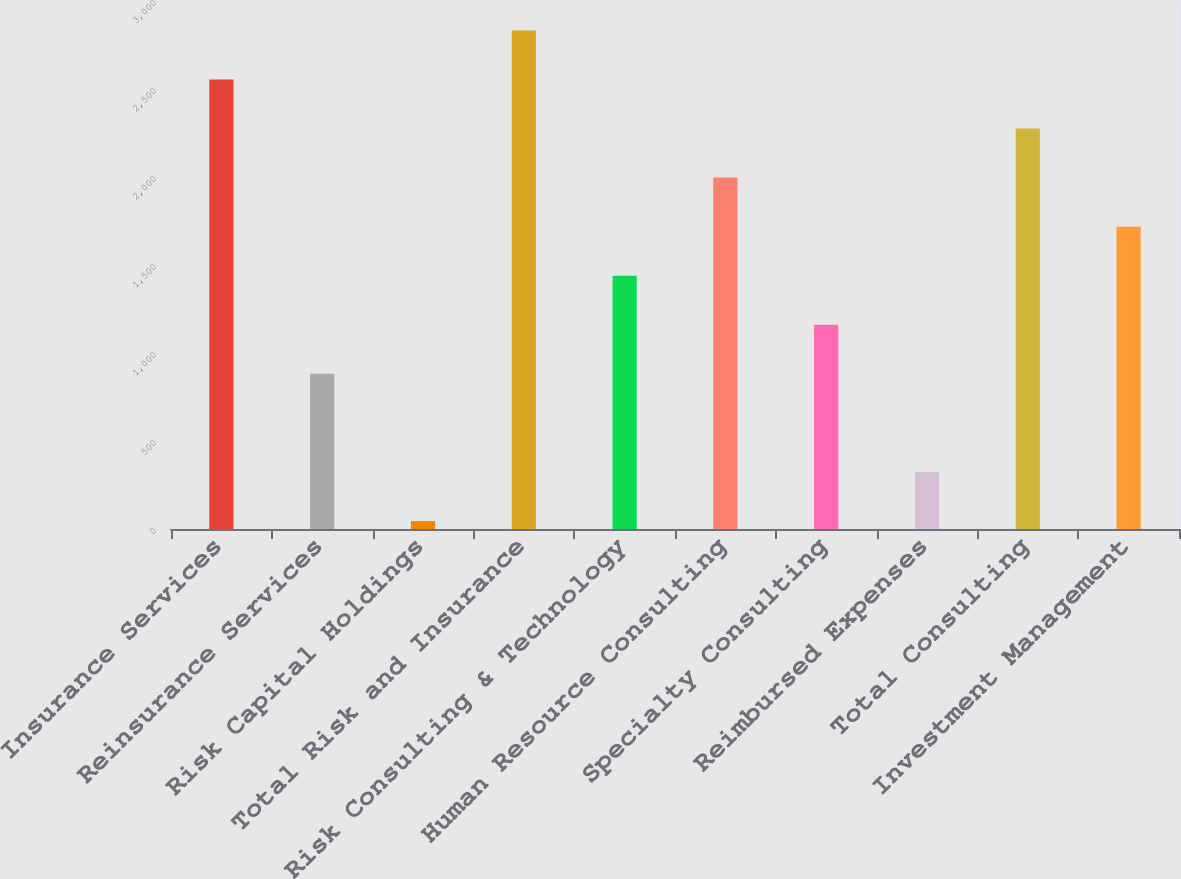Convert chart to OTSL. <chart><loc_0><loc_0><loc_500><loc_500><bar_chart><fcel>Insurance Services<fcel>Reinsurance Services<fcel>Risk Capital Holdings<fcel>Total Risk and Insurance<fcel>Risk Consulting & Technology<fcel>Human Resource Consulting<fcel>Specialty Consulting<fcel>Reimbursed Expenses<fcel>Total Consulting<fcel>Investment Management<nl><fcel>2554.2<fcel>881.4<fcel>45<fcel>2833<fcel>1439<fcel>1996.6<fcel>1160.2<fcel>323.8<fcel>2275.4<fcel>1717.8<nl></chart> 